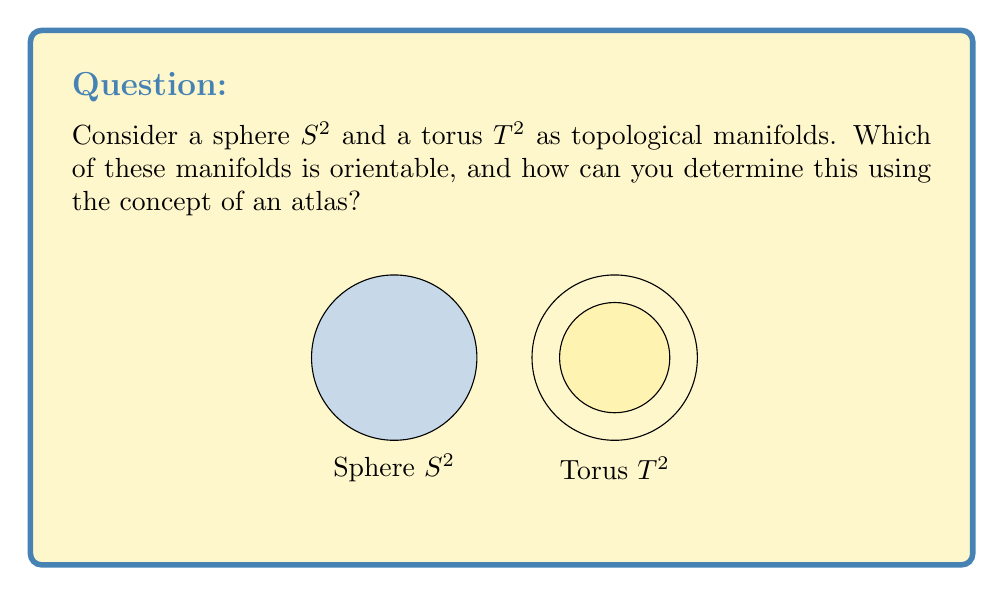Could you help me with this problem? Let's approach this step-by-step:

1) First, recall that a topological manifold is orientable if it has a consistent choice of orientation that agrees on the overlap of any two coordinate charts.

2) For the sphere $S^2$:
   a) We can cover $S^2$ with two charts: the sphere minus the north pole and the sphere minus the south pole.
   b) Each chart can be mapped to an open disk in $\mathbb{R}^2$ using stereographic projection.
   c) The transition map between these charts is smooth and orientation-preserving.
   d) Therefore, $S^2$ is orientable.

3) For the torus $T^2$:
   a) We can cover $T^2$ with a single chart by "cutting" the torus along one meridian and one parallel.
   b) This results in a rectangle, which can be mapped to an open subset of $\mathbb{R}^2$.
   c) The transition maps (identifying opposite edges of the rectangle) are smooth and orientation-preserving.
   d) Therefore, $T^2$ is also orientable.

4) To determine orientability using an atlas:
   a) Construct an atlas for the manifold.
   b) For each pair of overlapping charts, compute the Jacobian of the transition map.
   c) If the determinant of all Jacobians is positive, the manifold is orientable.
   d) If any determinant is negative, the manifold is non-orientable.

5) For both $S^2$ and $T^2$, all transition maps have Jacobians with positive determinants, confirming their orientability.
Answer: Both $S^2$ and $T^2$ are orientable. 